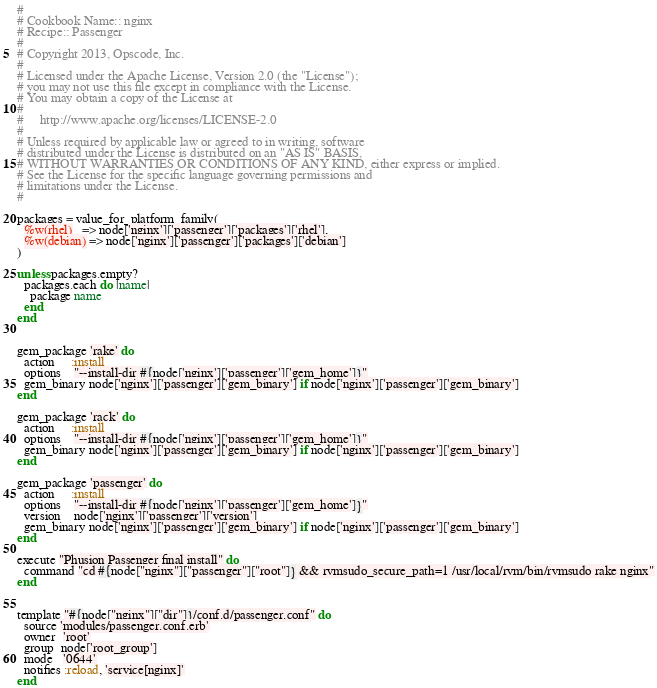<code> <loc_0><loc_0><loc_500><loc_500><_Ruby_>#
# Cookbook Name:: nginx
# Recipe:: Passenger
#
# Copyright 2013, Opscode, Inc.
#
# Licensed under the Apache License, Version 2.0 (the "License");
# you may not use this file except in compliance with the License.
# You may obtain a copy of the License at
#
#     http://www.apache.org/licenses/LICENSE-2.0
#
# Unless required by applicable law or agreed to in writing, software
# distributed under the License is distributed on an "AS IS" BASIS,
# WITHOUT WARRANTIES OR CONDITIONS OF ANY KIND, either express or implied.
# See the License for the specific language governing permissions and
# limitations under the License.
#

packages = value_for_platform_family(
  %w(rhel)   => node['nginx']['passenger']['packages']['rhel'],
  %w(debian) => node['nginx']['passenger']['packages']['debian']
)

unless packages.empty?
  packages.each do |name|
    package name
  end
end


gem_package 'rake' do
  action     :install
  options    "--install-dir #{node['nginx']['passenger']['gem_home']}"
  gem_binary node['nginx']['passenger']['gem_binary'] if node['nginx']['passenger']['gem_binary']
end

gem_package 'rack' do
  action     :install
  options    "--install-dir #{node['nginx']['passenger']['gem_home']}"
  gem_binary node['nginx']['passenger']['gem_binary'] if node['nginx']['passenger']['gem_binary']
end

gem_package 'passenger' do
  action     :install
  options    "--install-dir #{node['nginx']['passenger']['gem_home']}"
  version    node['nginx']['passenger']['version']
  gem_binary node['nginx']['passenger']['gem_binary'] if node['nginx']['passenger']['gem_binary']
end

execute "Phusion Passenger final install" do
  command "cd #{node["nginx"]["passenger"]["root"]} && rvmsudo_secure_path=1 /usr/local/rvm/bin/rvmsudo rake nginx"
end


template "#{node["nginx"]["dir"]}/conf.d/passenger.conf" do
  source 'modules/passenger.conf.erb'
  owner  'root'
  group  node['root_group']
  mode   '0644'
  notifies :reload, 'service[nginx]'
end
</code> 